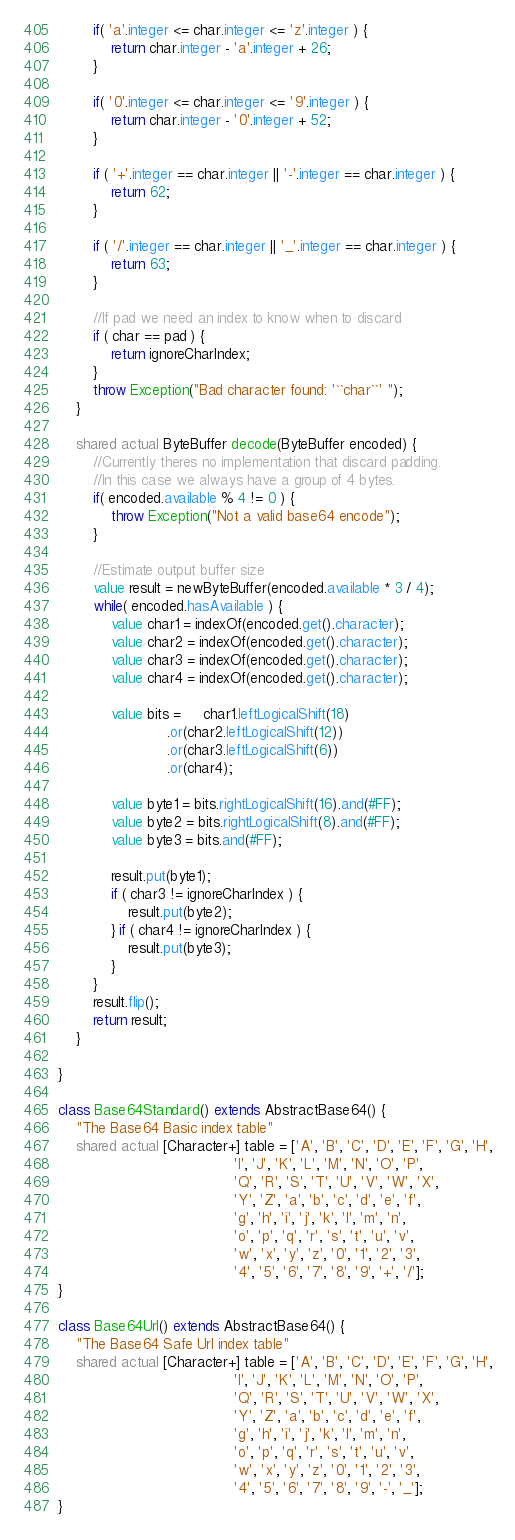<code> <loc_0><loc_0><loc_500><loc_500><_Ceylon_>
        if( 'a'.integer <= char.integer <= 'z'.integer ) {
            return char.integer - 'a'.integer + 26;
        }

        if( '0'.integer <= char.integer <= '9'.integer ) {
            return char.integer - '0'.integer + 52;
        }

        if ( '+'.integer == char.integer || '-'.integer == char.integer ) {
            return 62;
        }

        if ( '/'.integer == char.integer || '_'.integer == char.integer ) {
            return 63;
        }

        //If pad we need an index to know when to discard 
        if ( char == pad ) {
            return ignoreCharIndex;
        }
        throw Exception("Bad character found: '``char``' ");
    }

    shared actual ByteBuffer decode(ByteBuffer encoded) {
        //Currently theres no implementation that discard padding. 
        //In this case we always have a group of 4 bytes.
        if( encoded.available % 4 != 0 ) {
            throw Exception("Not a valid base64 encode");
        }

        //Estimate output buffer size
        value result = newByteBuffer(encoded.available * 3 / 4);
        while( encoded.hasAvailable ) {
            value char1 = indexOf(encoded.get().character);
            value char2 = indexOf(encoded.get().character);
            value char3 = indexOf(encoded.get().character);
            value char4 = indexOf(encoded.get().character);

            value bits =     char1.leftLogicalShift(18)
                         .or(char2.leftLogicalShift(12))
                         .or(char3.leftLogicalShift(6))
                         .or(char4);

            value byte1 = bits.rightLogicalShift(16).and(#FF);
            value byte2 = bits.rightLogicalShift(8).and(#FF);
            value byte3 = bits.and(#FF);

            result.put(byte1);
            if ( char3 != ignoreCharIndex ) {
                result.put(byte2);
            } if ( char4 != ignoreCharIndex ) {
                result.put(byte3);
            }
        }
        result.flip();
        return result;
    }

}

class Base64Standard() extends AbstractBase64() {
    "The Base64 Basic index table"
    shared actual [Character+] table = ['A', 'B', 'C', 'D', 'E', 'F', 'G', 'H',
                                        'I', 'J', 'K', 'L', 'M', 'N', 'O', 'P',
                                        'Q', 'R', 'S', 'T', 'U', 'V', 'W', 'X',
                                        'Y', 'Z', 'a', 'b', 'c', 'd', 'e', 'f',
                                        'g', 'h', 'i', 'j', 'k', 'l', 'm', 'n',
                                        'o', 'p', 'q', 'r', 's', 't', 'u', 'v',
                                        'w', 'x', 'y', 'z', '0', '1', '2', '3',
                                        '4', '5', '6', '7', '8', '9', '+', '/'];
}

class Base64Url() extends AbstractBase64() {
    "The Base64 Safe Url index table"
    shared actual [Character+] table = ['A', 'B', 'C', 'D', 'E', 'F', 'G', 'H',
                                        'I', 'J', 'K', 'L', 'M', 'N', 'O', 'P',
                                        'Q', 'R', 'S', 'T', 'U', 'V', 'W', 'X',
                                        'Y', 'Z', 'a', 'b', 'c', 'd', 'e', 'f',
                                        'g', 'h', 'i', 'j', 'k', 'l', 'm', 'n',
                                        'o', 'p', 'q', 'r', 's', 't', 'u', 'v',
                                        'w', 'x', 'y', 'z', '0', '1', '2', '3',
                                        '4', '5', '6', '7', '8', '9', '-', '_'];
}
</code> 